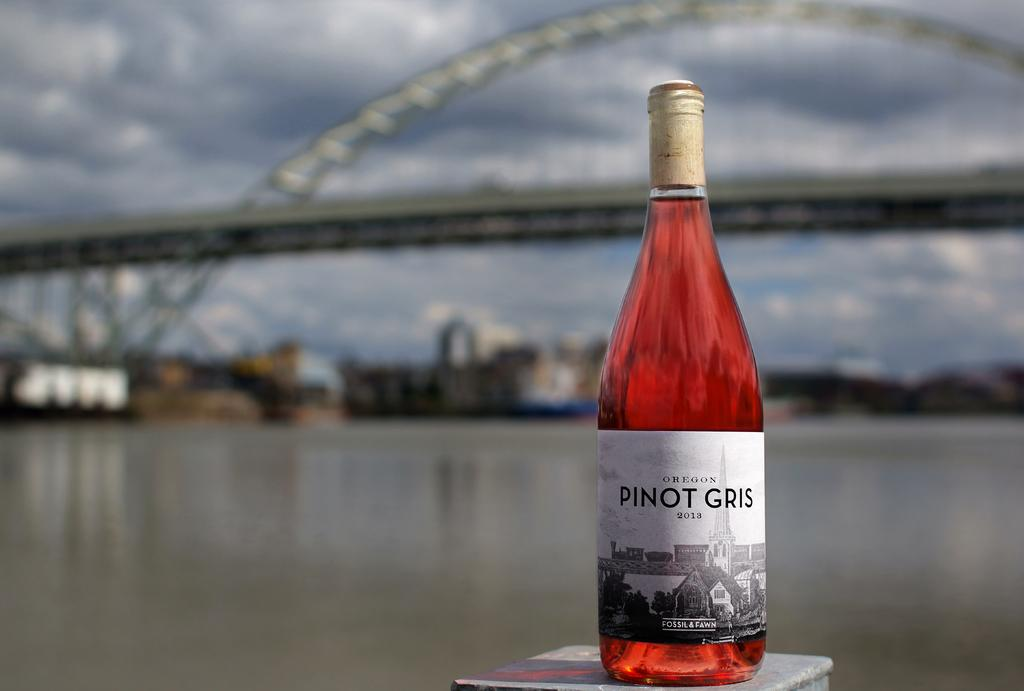<image>
Offer a succinct explanation of the picture presented. A bottle of Pinot Gris with a bridge in the background. 